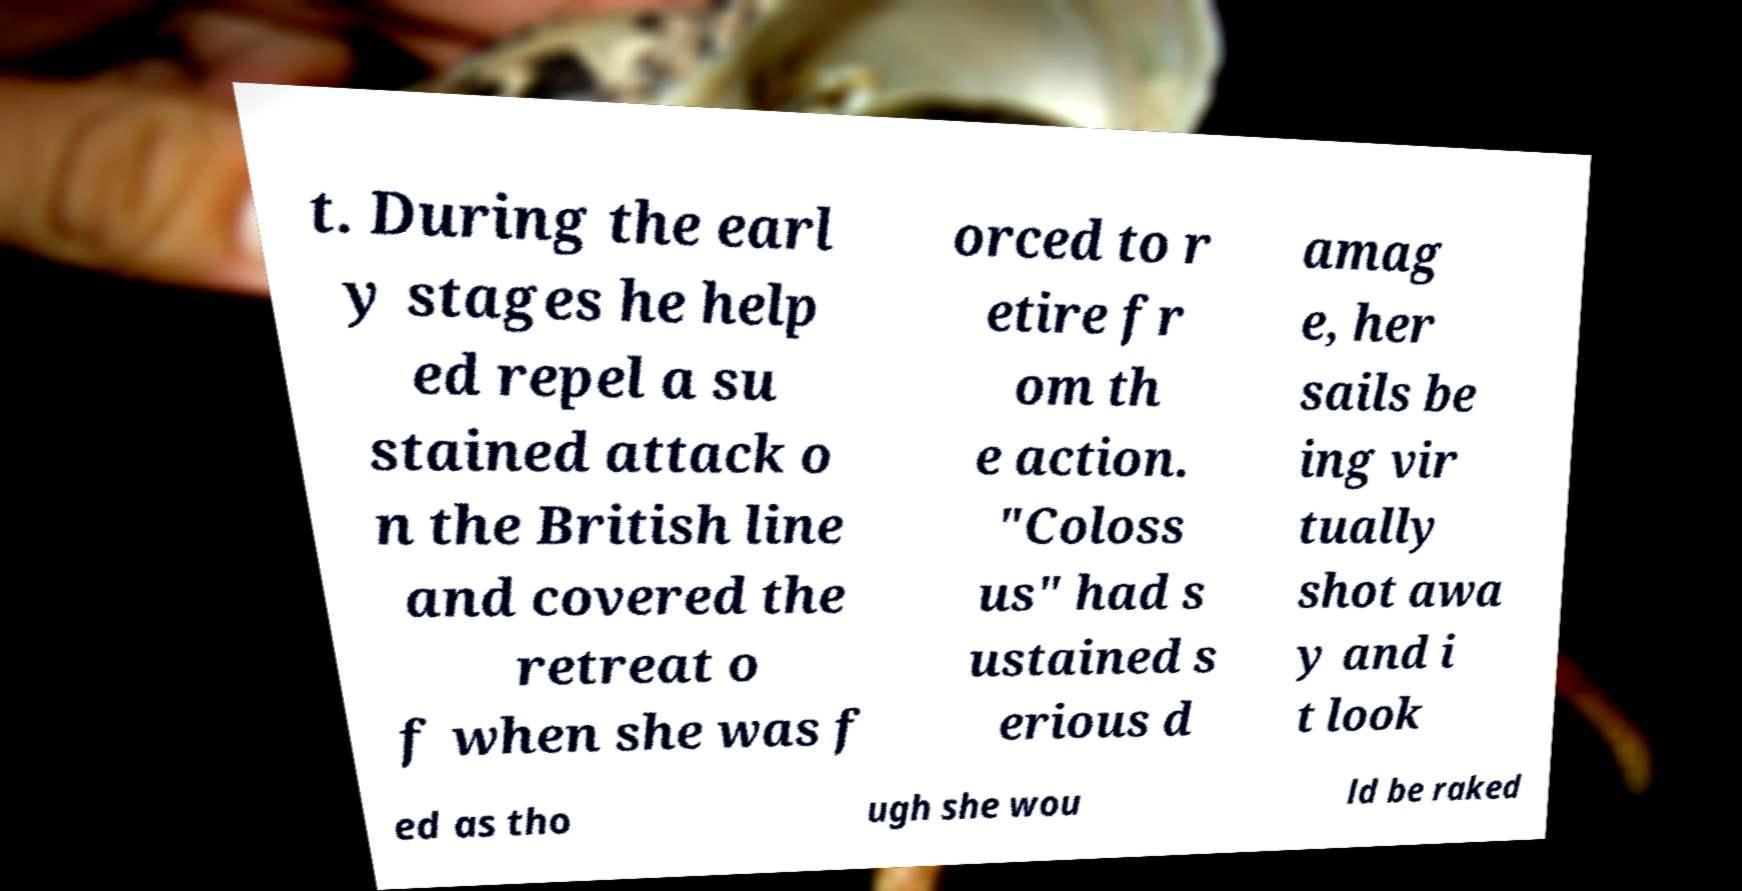Please identify and transcribe the text found in this image. t. During the earl y stages he help ed repel a su stained attack o n the British line and covered the retreat o f when she was f orced to r etire fr om th e action. "Coloss us" had s ustained s erious d amag e, her sails be ing vir tually shot awa y and i t look ed as tho ugh she wou ld be raked 